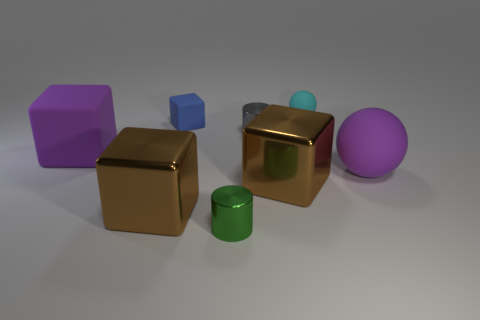Add 1 tiny green matte blocks. How many objects exist? 9 Subtract all cylinders. How many objects are left? 6 Add 2 purple balls. How many purple balls are left? 3 Add 3 blue things. How many blue things exist? 4 Subtract 0 gray blocks. How many objects are left? 8 Subtract all small green cylinders. Subtract all brown objects. How many objects are left? 5 